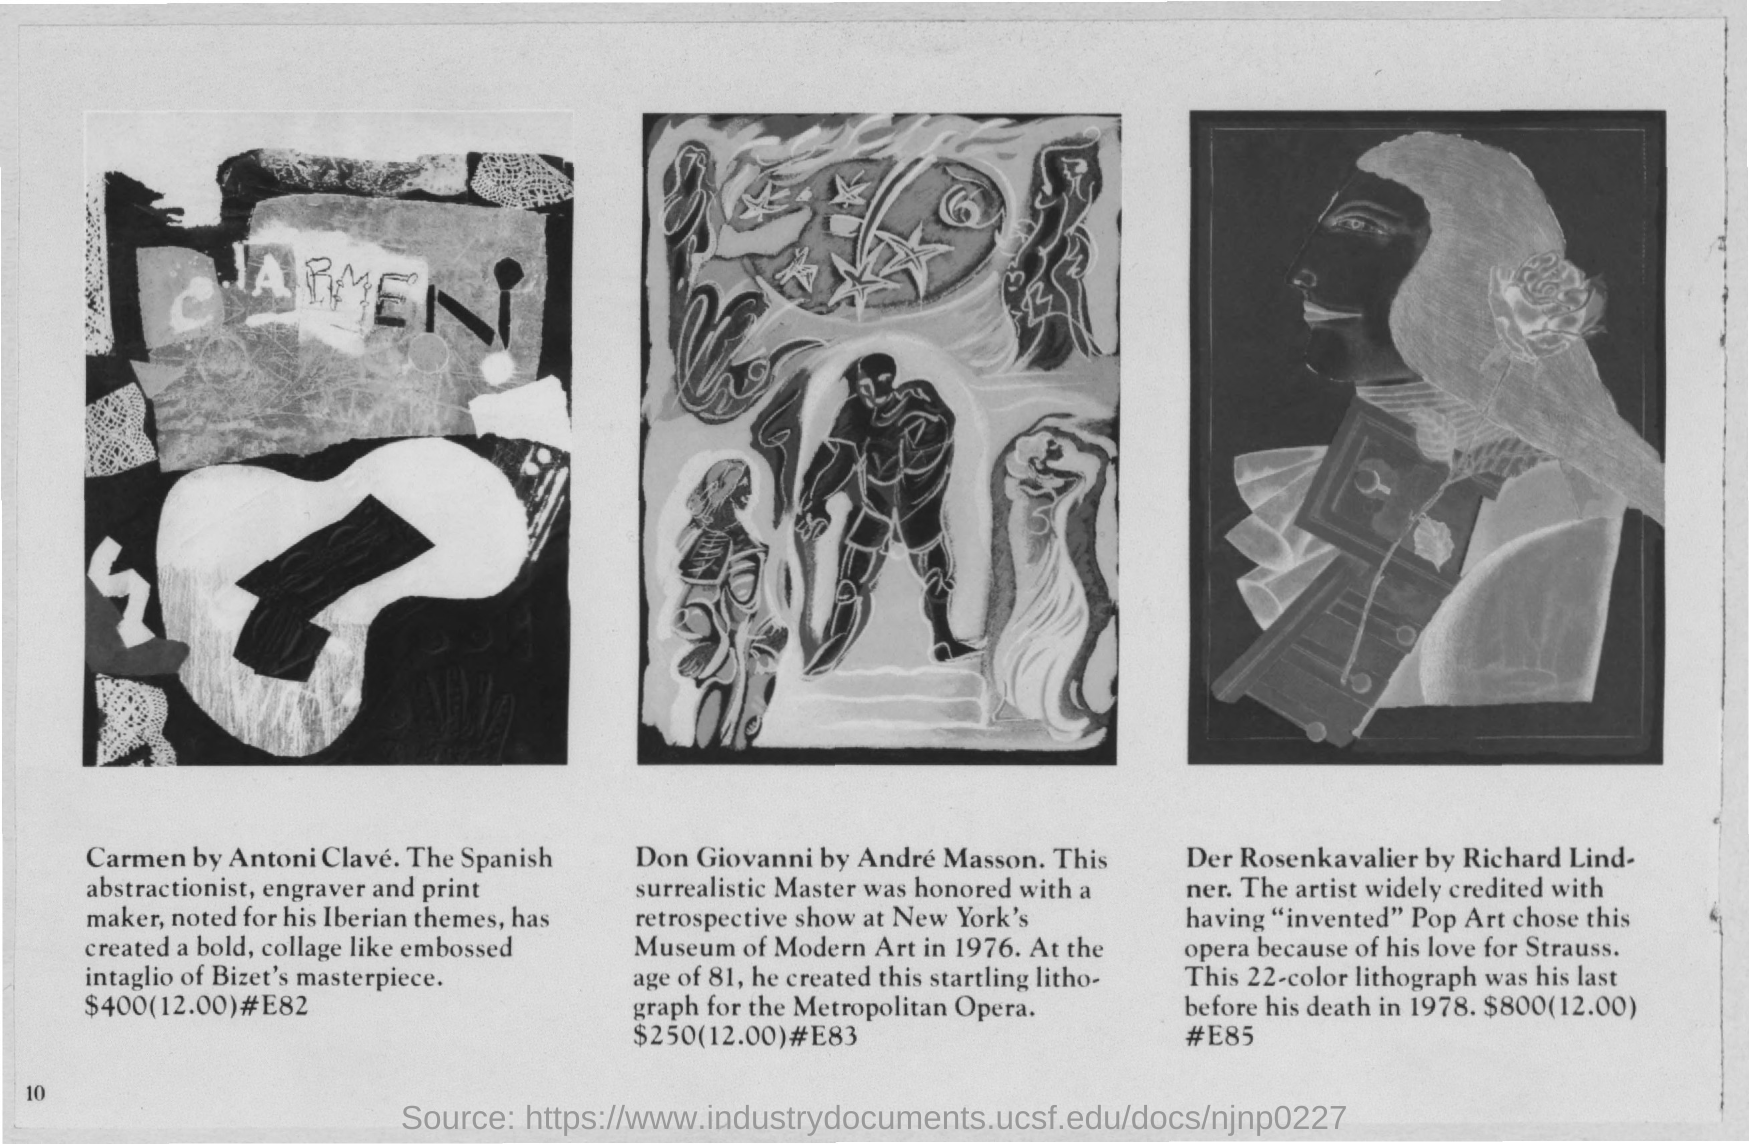What is the Price of "Carmen by Antoni Clave"?
Your response must be concise. $400. What is the Price of "Don Giovanni by Andre Masson"?
Give a very brief answer. $250. 